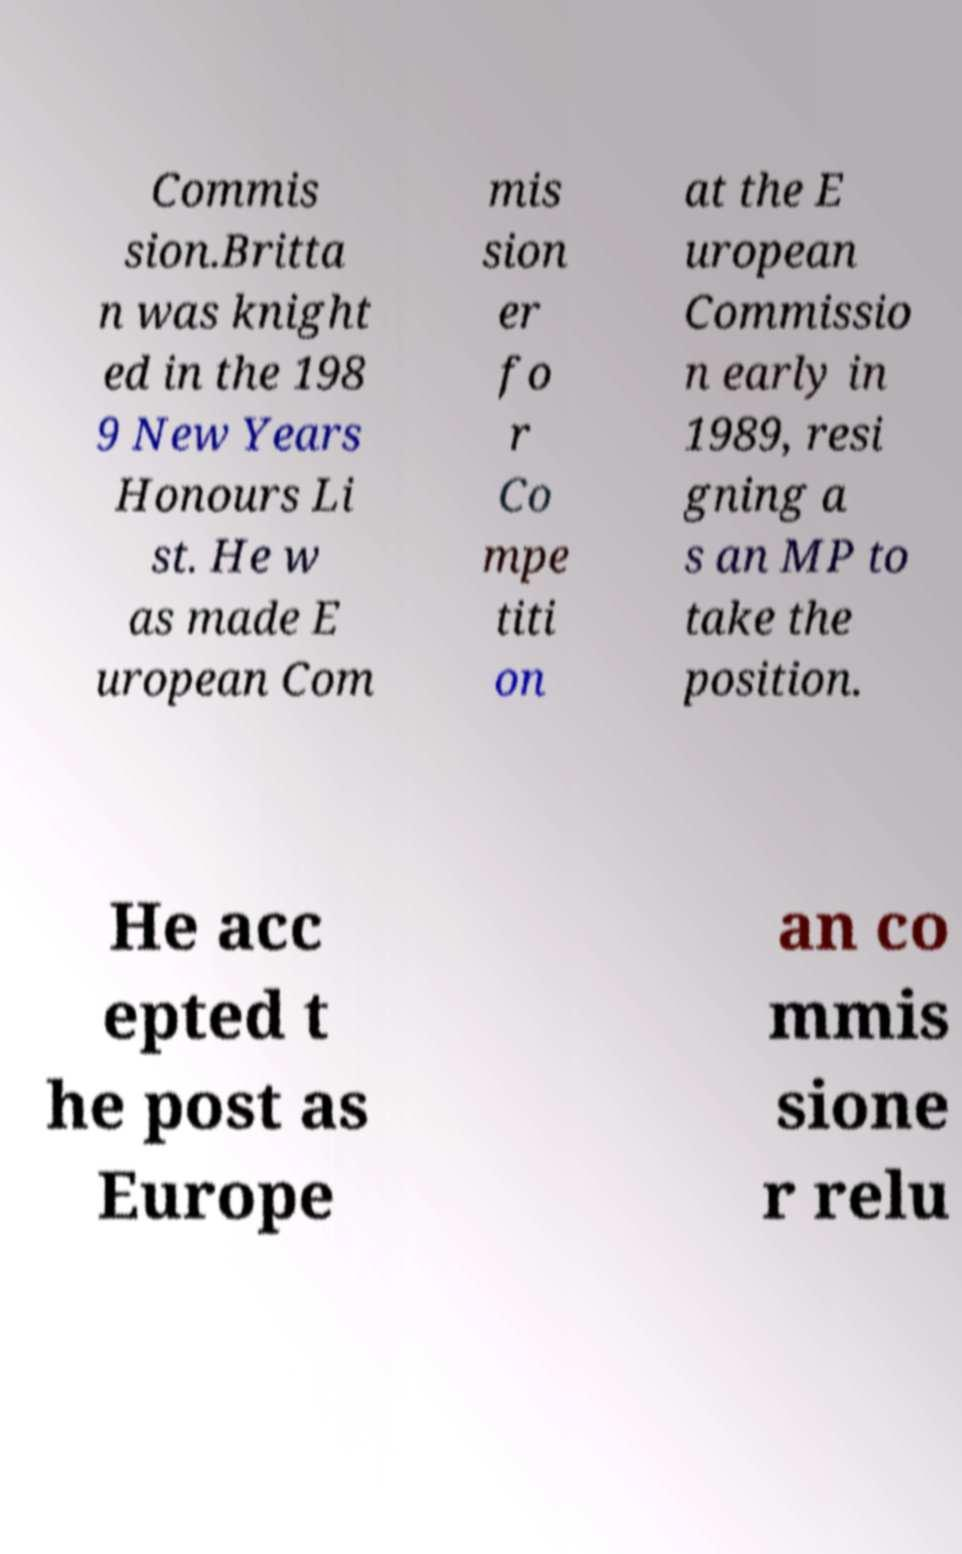There's text embedded in this image that I need extracted. Can you transcribe it verbatim? Commis sion.Britta n was knight ed in the 198 9 New Years Honours Li st. He w as made E uropean Com mis sion er fo r Co mpe titi on at the E uropean Commissio n early in 1989, resi gning a s an MP to take the position. He acc epted t he post as Europe an co mmis sione r relu 